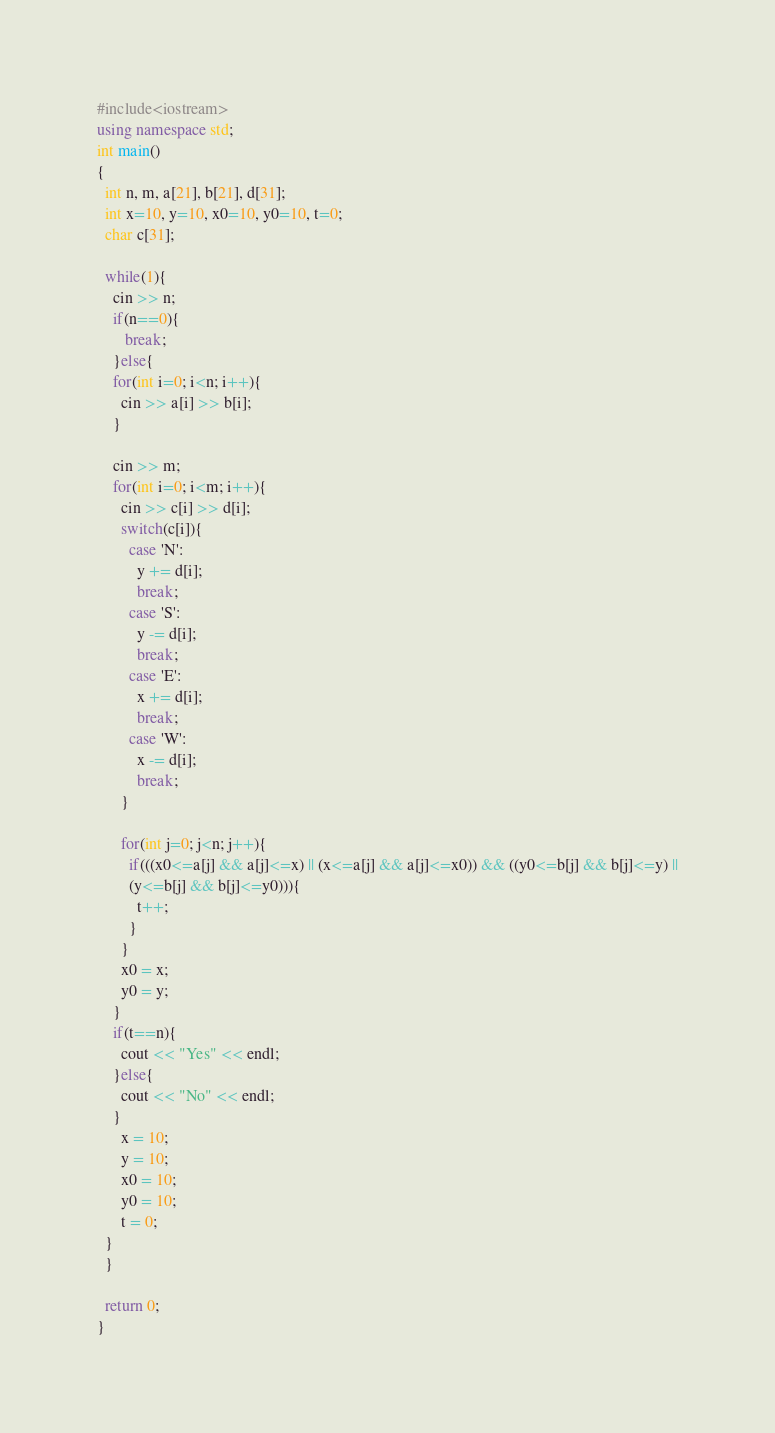<code> <loc_0><loc_0><loc_500><loc_500><_C++_>#include<iostream>
using namespace std;
int main()
{
  int n, m, a[21], b[21], d[31];
  int x=10, y=10, x0=10, y0=10, t=0;
  char c[31];

  while(1){
    cin >> n;
    if(n==0){
       break;
    }else{
    for(int i=0; i<n; i++){
      cin >> a[i] >> b[i];
    }

    cin >> m;
    for(int i=0; i<m; i++){
      cin >> c[i] >> d[i];
      switch(c[i]){
        case 'N':
          y += d[i];
          break;
        case 'S':
          y -= d[i];
          break;
        case 'E':
          x += d[i];
          break;
        case 'W':
          x -= d[i];
          break;
      }

      for(int j=0; j<n; j++){
        if(((x0<=a[j] && a[j]<=x) || (x<=a[j] && a[j]<=x0)) && ((y0<=b[j] && b[j]<=y) ||
        (y<=b[j] && b[j]<=y0))){
          t++;
        }
      }
      x0 = x;
      y0 = y;
    }
    if(t==n){
      cout << "Yes" << endl;
    }else{
      cout << "No" << endl;
    }
      x = 10;
      y = 10;
      x0 = 10;
      y0 = 10;
      t = 0;
  } 
  }

  return 0;
}</code> 